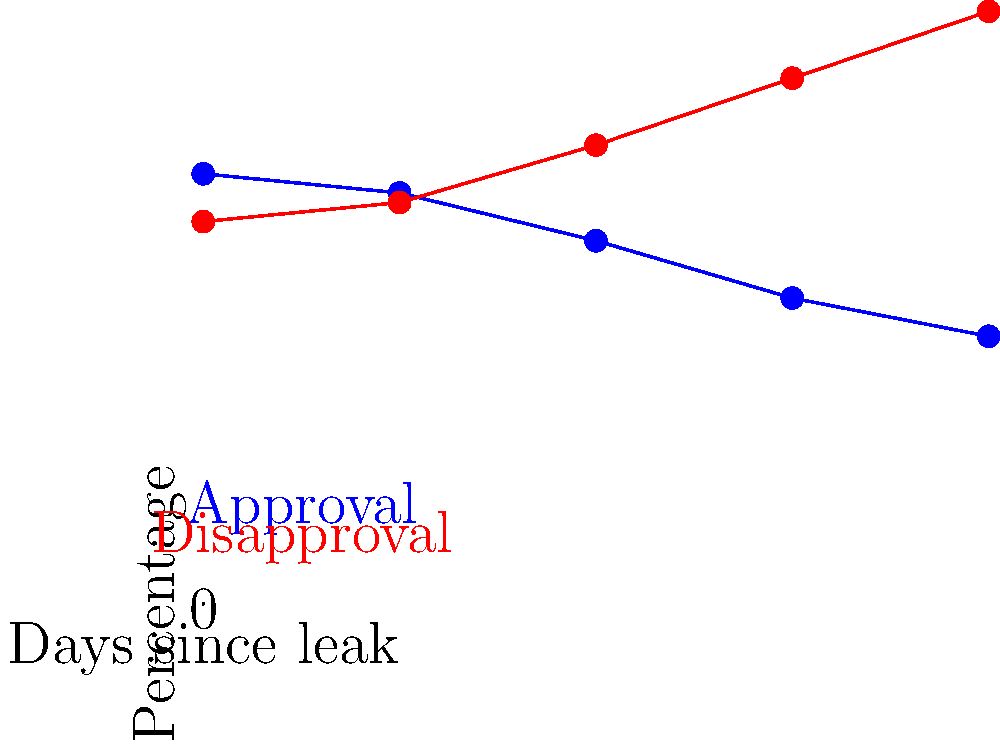Based on the trend lines shown in the graph, what is the estimated percentage point difference between approval and disapproval ratings 5 days after the information leak? To solve this question, we need to follow these steps:

1. Observe the trends in both approval and disapproval ratings over the 5-day period shown.
2. Extrapolate these trends to estimate the values for both ratings on day 5.
3. Calculate the difference between the extrapolated values.

Step 1: Observing trends
- Approval rating (blue line) is steadily decreasing.
- Disapproval rating (red line) is steadily increasing.

Step 2: Extrapolating trends
- Approval rating:
  * Starts at 45% on day 0
  * Ends at 28% on day 4
  * Average daily decrease: (45% - 28%) / 4 = 4.25%
  * Estimated value on day 5: 28% - 4.25% = 23.75%

- Disapproval rating:
  * Starts at 40% on day 0
  * Ends at 62% on day 4
  * Average daily increase: (62% - 40%) / 4 = 5.5%
  * Estimated value on day 5: 62% + 5.5% = 67.5%

Step 3: Calculating the difference
Difference = Disapproval rating - Approval rating
           = 67.5% - 23.75% = 43.75%

Rounding to the nearest whole number: 44 percentage points
Answer: 44 percentage points 